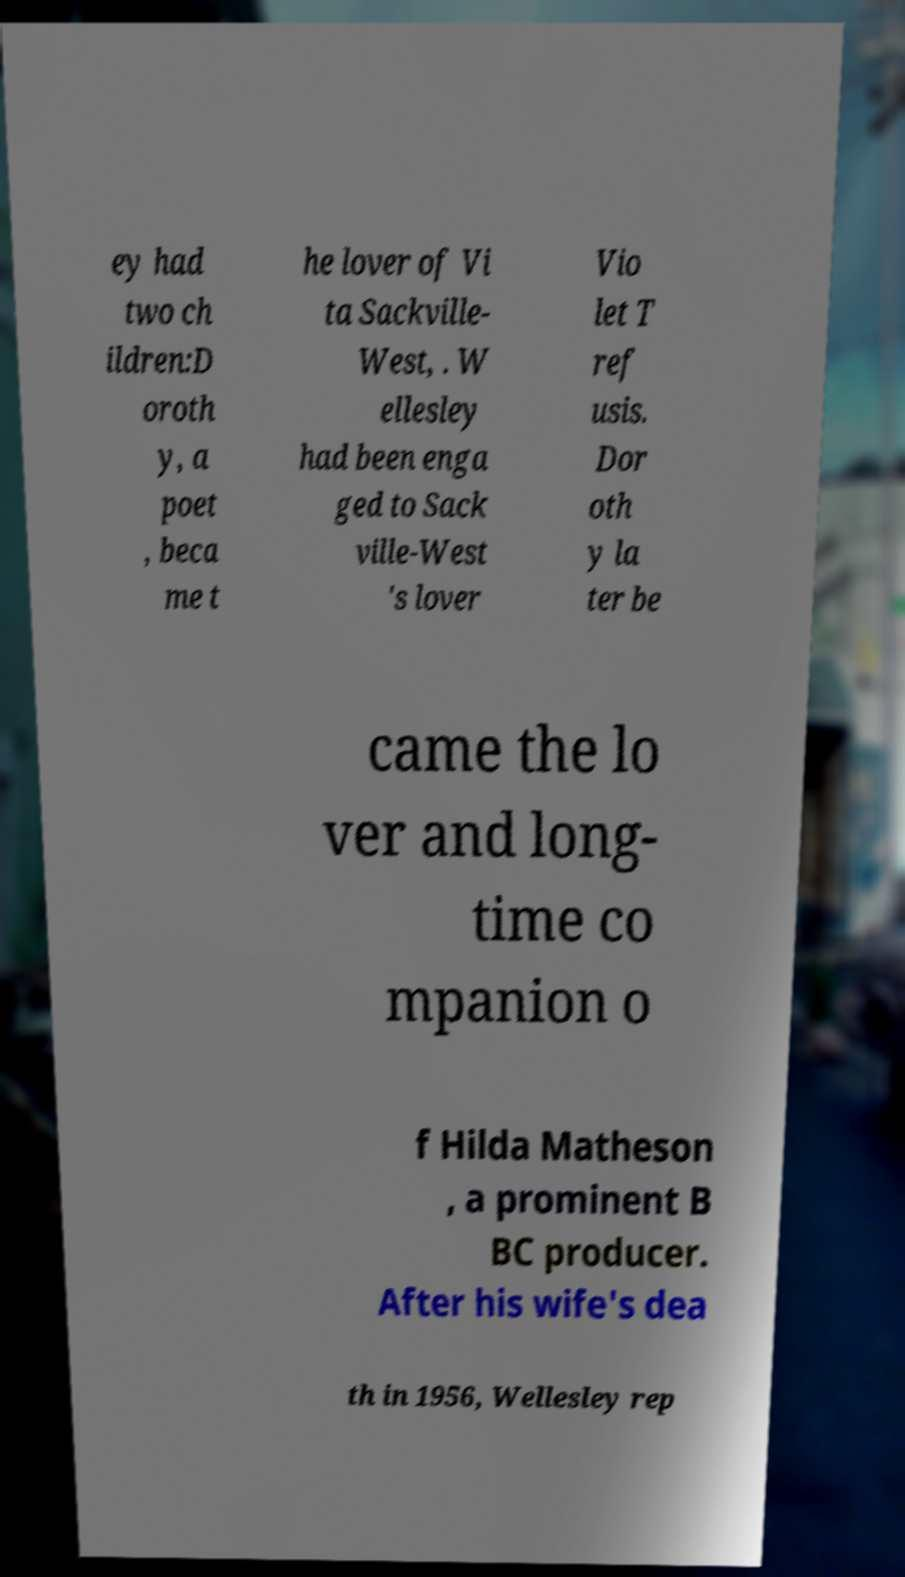Could you extract and type out the text from this image? ey had two ch ildren:D oroth y, a poet , beca me t he lover of Vi ta Sackville- West, . W ellesley had been enga ged to Sack ville-West 's lover Vio let T ref usis. Dor oth y la ter be came the lo ver and long- time co mpanion o f Hilda Matheson , a prominent B BC producer. After his wife's dea th in 1956, Wellesley rep 